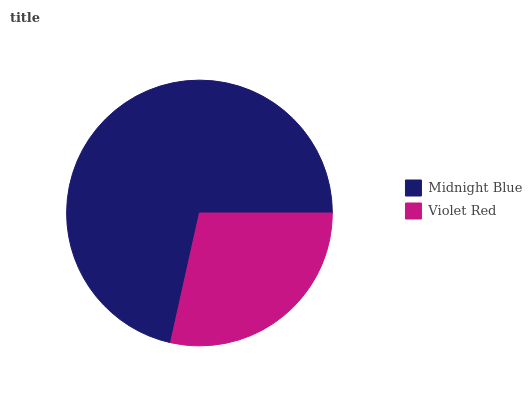Is Violet Red the minimum?
Answer yes or no. Yes. Is Midnight Blue the maximum?
Answer yes or no. Yes. Is Violet Red the maximum?
Answer yes or no. No. Is Midnight Blue greater than Violet Red?
Answer yes or no. Yes. Is Violet Red less than Midnight Blue?
Answer yes or no. Yes. Is Violet Red greater than Midnight Blue?
Answer yes or no. No. Is Midnight Blue less than Violet Red?
Answer yes or no. No. Is Midnight Blue the high median?
Answer yes or no. Yes. Is Violet Red the low median?
Answer yes or no. Yes. Is Violet Red the high median?
Answer yes or no. No. Is Midnight Blue the low median?
Answer yes or no. No. 